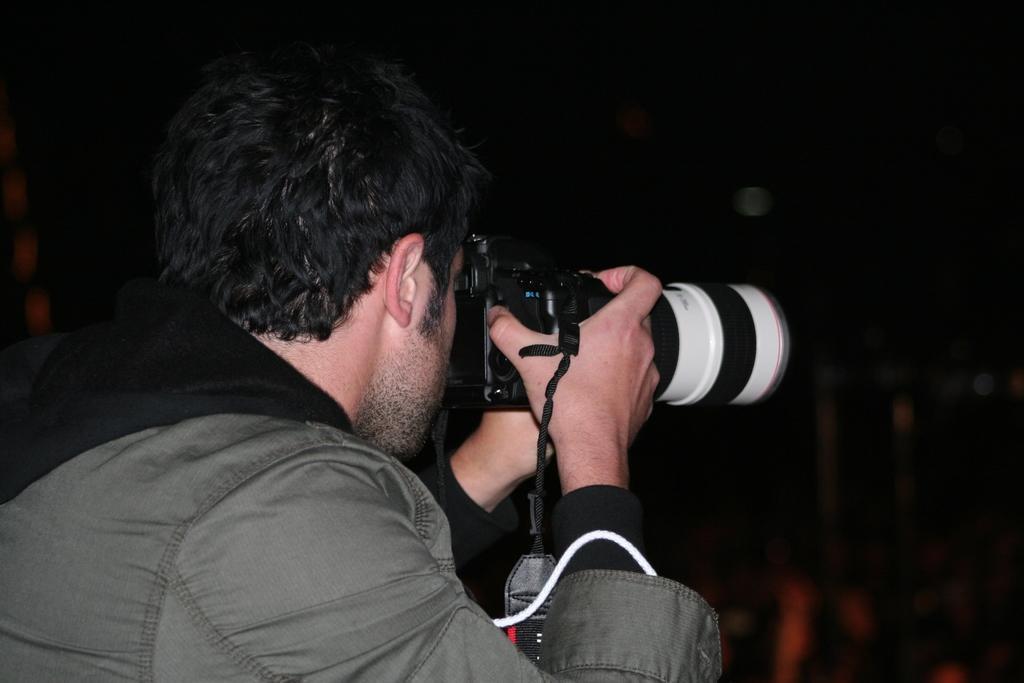In one or two sentences, can you explain what this image depicts? In this image we can see a person clicking a picture with a camera. 